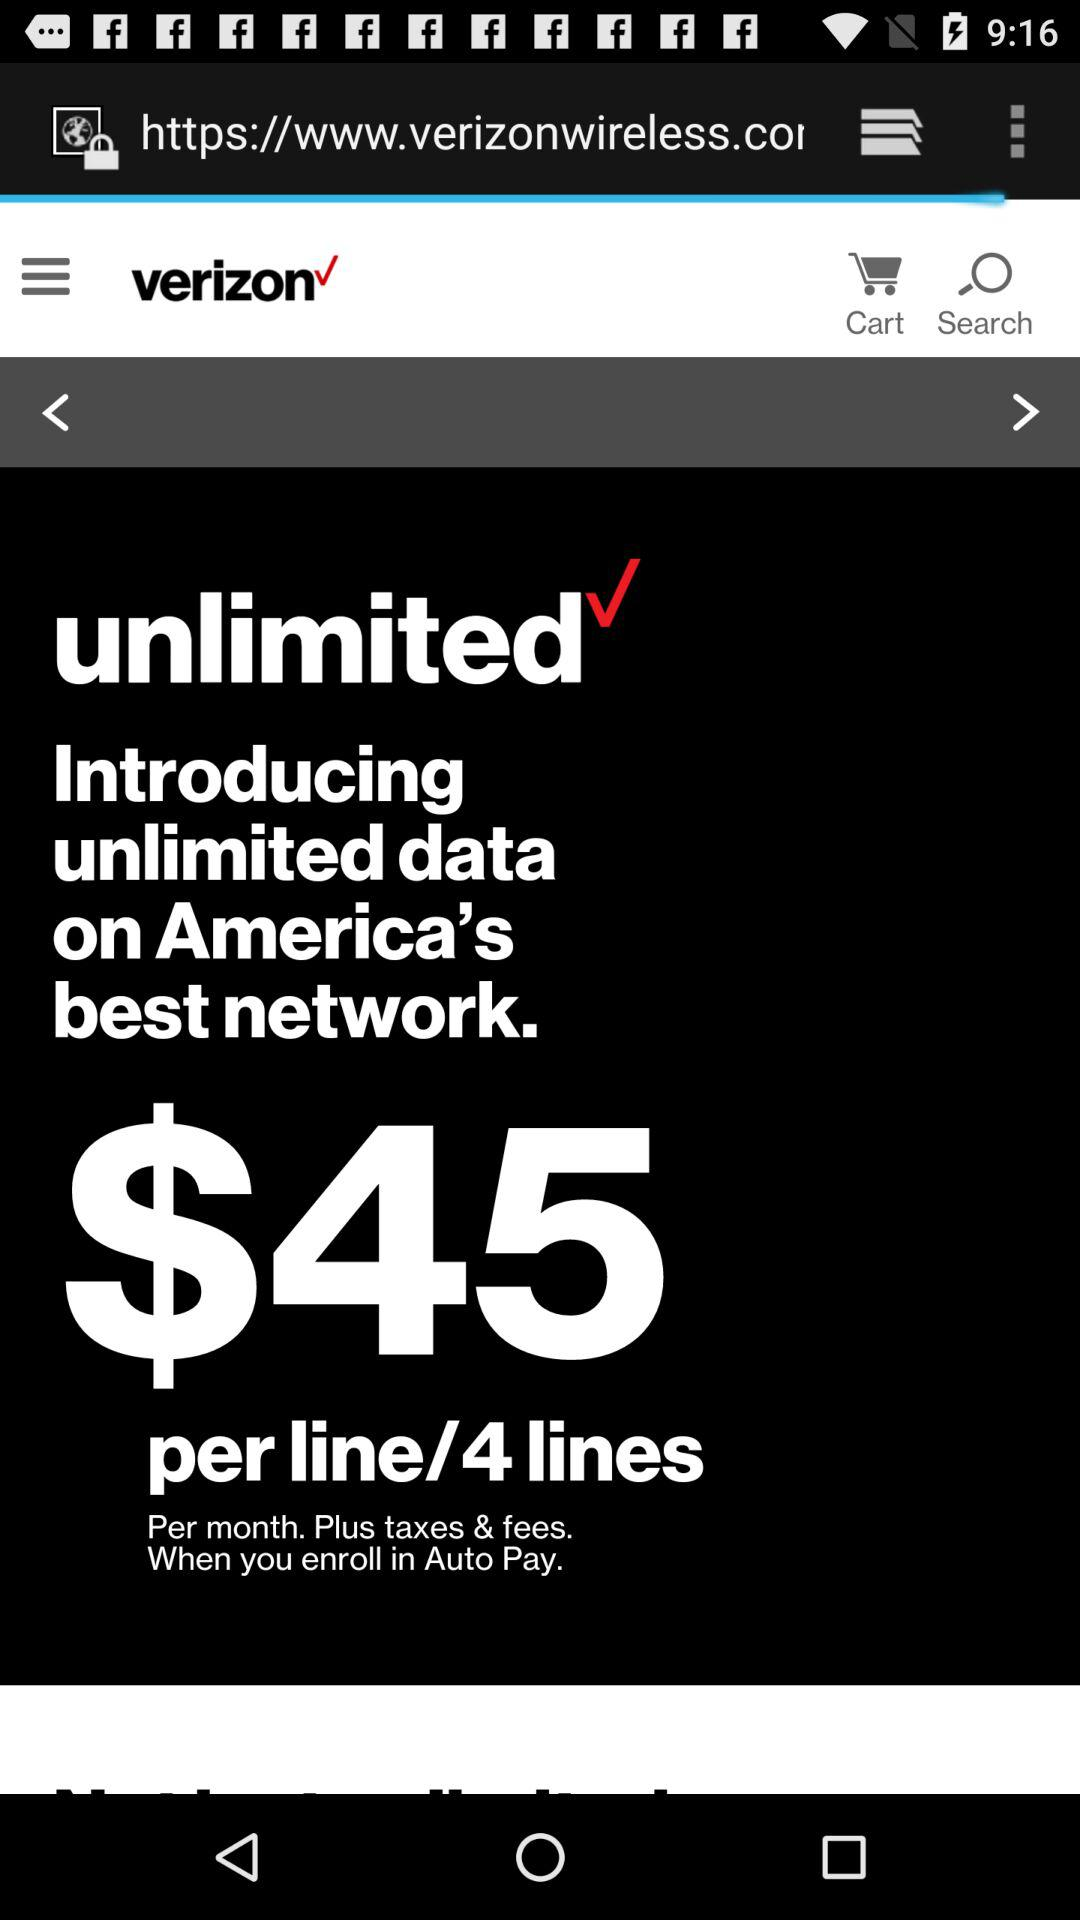What is the name of the application? The name of the application is "verizon". 